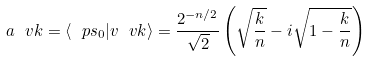Convert formula to latex. <formula><loc_0><loc_0><loc_500><loc_500>a _ { \ } v k = \langle \ p s _ { 0 } | v _ { \ } v k \rangle = \frac { 2 ^ { - n / 2 } } { \sqrt { 2 } } \left ( \sqrt { \frac { k } { n } } - i \sqrt { 1 - \frac { k } { n } } \right )</formula> 